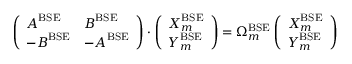<formula> <loc_0><loc_0><loc_500><loc_500>\left ( \begin{array} { l l } { A ^ { B S E } } & { B ^ { B S E } } \\ { - B ^ { B S E } } & { - A ^ { B S E } } \end{array} \right ) \cdot \left ( \begin{array} { l } { X _ { m } ^ { B S E } } \\ { Y _ { m } ^ { B S E } } \end{array} \right ) = \Omega _ { m } ^ { B S E } \left ( \begin{array} { l } { X _ { m } ^ { B S E } } \\ { Y _ { m } ^ { B S E } } \end{array} \right )</formula> 